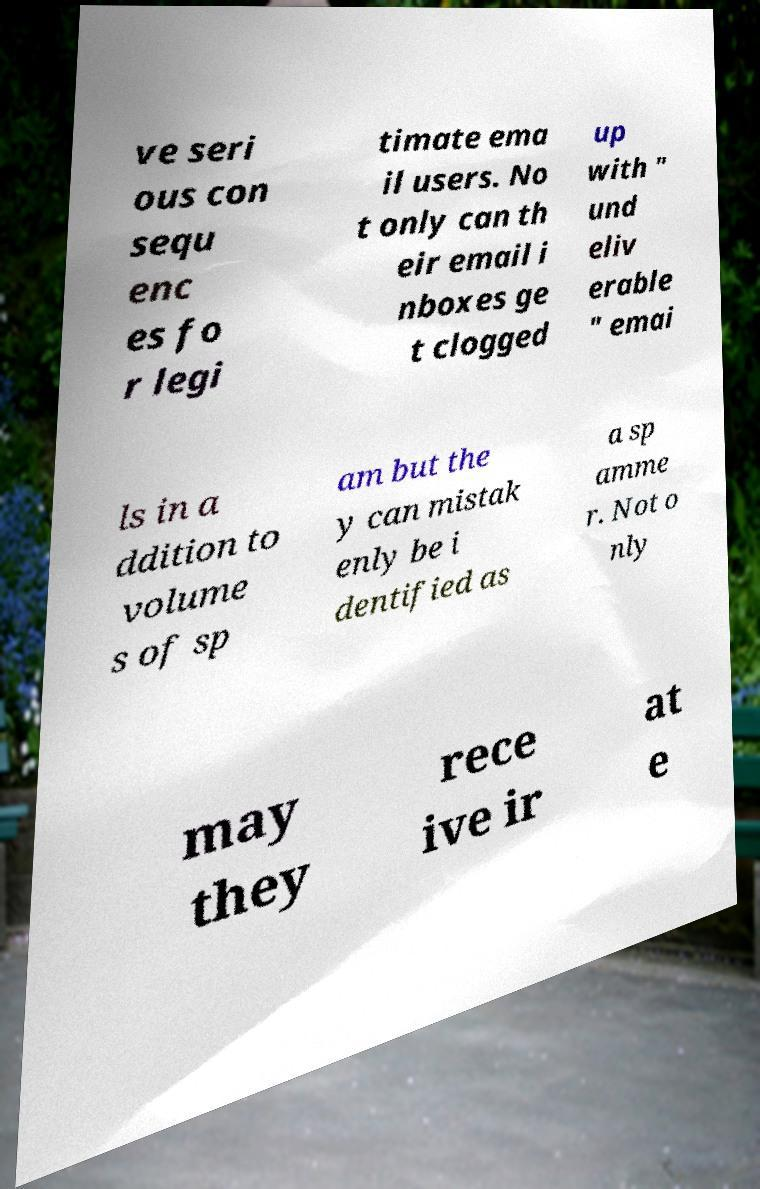What messages or text are displayed in this image? I need them in a readable, typed format. ve seri ous con sequ enc es fo r legi timate ema il users. No t only can th eir email i nboxes ge t clogged up with " und eliv erable " emai ls in a ddition to volume s of sp am but the y can mistak enly be i dentified as a sp amme r. Not o nly may they rece ive ir at e 